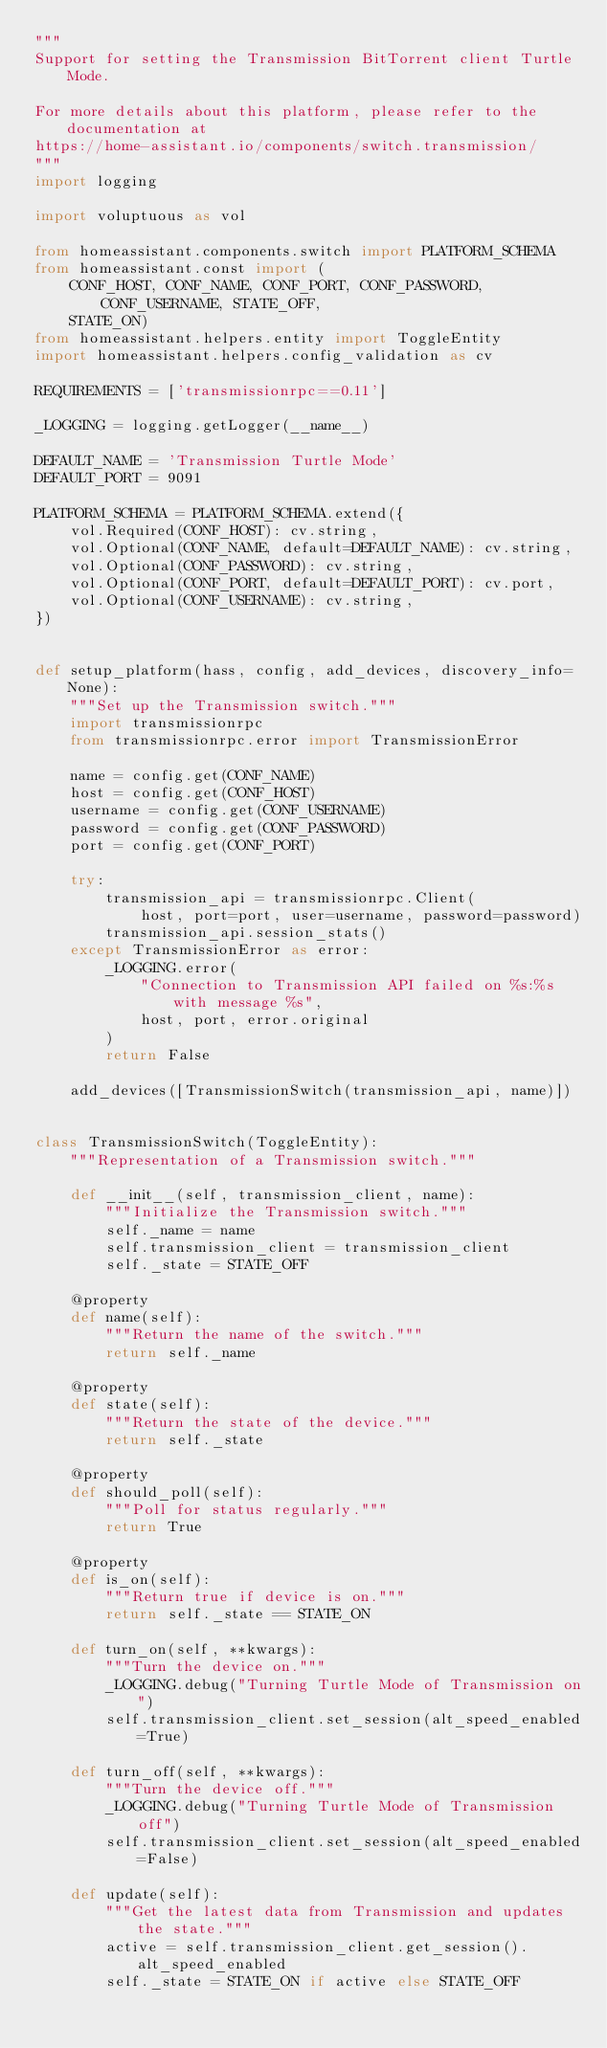Convert code to text. <code><loc_0><loc_0><loc_500><loc_500><_Python_>"""
Support for setting the Transmission BitTorrent client Turtle Mode.

For more details about this platform, please refer to the documentation at
https://home-assistant.io/components/switch.transmission/
"""
import logging

import voluptuous as vol

from homeassistant.components.switch import PLATFORM_SCHEMA
from homeassistant.const import (
    CONF_HOST, CONF_NAME, CONF_PORT, CONF_PASSWORD, CONF_USERNAME, STATE_OFF,
    STATE_ON)
from homeassistant.helpers.entity import ToggleEntity
import homeassistant.helpers.config_validation as cv

REQUIREMENTS = ['transmissionrpc==0.11']

_LOGGING = logging.getLogger(__name__)

DEFAULT_NAME = 'Transmission Turtle Mode'
DEFAULT_PORT = 9091

PLATFORM_SCHEMA = PLATFORM_SCHEMA.extend({
    vol.Required(CONF_HOST): cv.string,
    vol.Optional(CONF_NAME, default=DEFAULT_NAME): cv.string,
    vol.Optional(CONF_PASSWORD): cv.string,
    vol.Optional(CONF_PORT, default=DEFAULT_PORT): cv.port,
    vol.Optional(CONF_USERNAME): cv.string,
})


def setup_platform(hass, config, add_devices, discovery_info=None):
    """Set up the Transmission switch."""
    import transmissionrpc
    from transmissionrpc.error import TransmissionError

    name = config.get(CONF_NAME)
    host = config.get(CONF_HOST)
    username = config.get(CONF_USERNAME)
    password = config.get(CONF_PASSWORD)
    port = config.get(CONF_PORT)

    try:
        transmission_api = transmissionrpc.Client(
            host, port=port, user=username, password=password)
        transmission_api.session_stats()
    except TransmissionError as error:
        _LOGGING.error(
            "Connection to Transmission API failed on %s:%s with message %s",
            host, port, error.original
        )
        return False

    add_devices([TransmissionSwitch(transmission_api, name)])


class TransmissionSwitch(ToggleEntity):
    """Representation of a Transmission switch."""

    def __init__(self, transmission_client, name):
        """Initialize the Transmission switch."""
        self._name = name
        self.transmission_client = transmission_client
        self._state = STATE_OFF

    @property
    def name(self):
        """Return the name of the switch."""
        return self._name

    @property
    def state(self):
        """Return the state of the device."""
        return self._state

    @property
    def should_poll(self):
        """Poll for status regularly."""
        return True

    @property
    def is_on(self):
        """Return true if device is on."""
        return self._state == STATE_ON

    def turn_on(self, **kwargs):
        """Turn the device on."""
        _LOGGING.debug("Turning Turtle Mode of Transmission on")
        self.transmission_client.set_session(alt_speed_enabled=True)

    def turn_off(self, **kwargs):
        """Turn the device off."""
        _LOGGING.debug("Turning Turtle Mode of Transmission off")
        self.transmission_client.set_session(alt_speed_enabled=False)

    def update(self):
        """Get the latest data from Transmission and updates the state."""
        active = self.transmission_client.get_session().alt_speed_enabled
        self._state = STATE_ON if active else STATE_OFF
</code> 